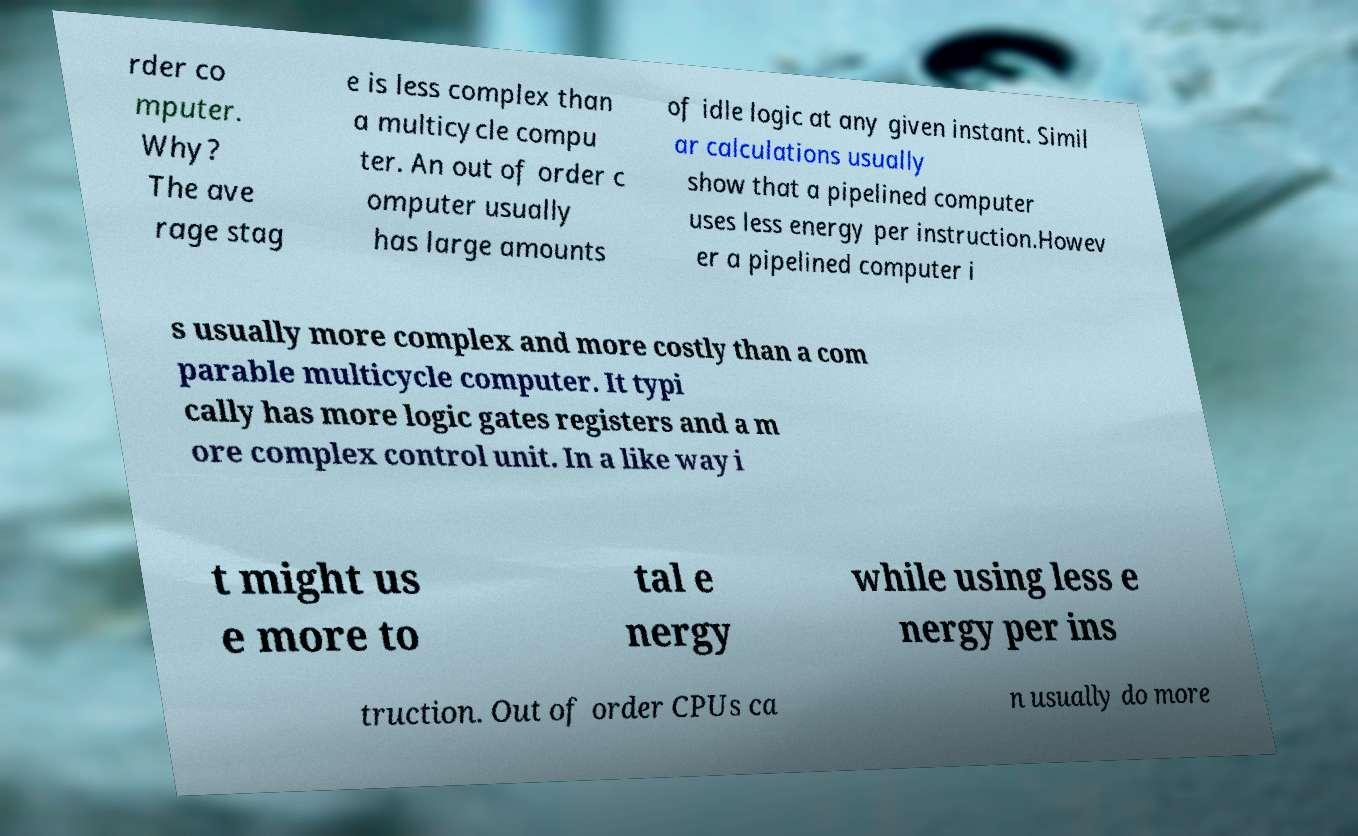Could you assist in decoding the text presented in this image and type it out clearly? rder co mputer. Why? The ave rage stag e is less complex than a multicycle compu ter. An out of order c omputer usually has large amounts of idle logic at any given instant. Simil ar calculations usually show that a pipelined computer uses less energy per instruction.Howev er a pipelined computer i s usually more complex and more costly than a com parable multicycle computer. It typi cally has more logic gates registers and a m ore complex control unit. In a like way i t might us e more to tal e nergy while using less e nergy per ins truction. Out of order CPUs ca n usually do more 